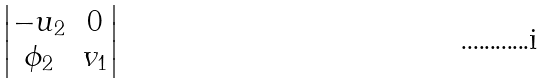<formula> <loc_0><loc_0><loc_500><loc_500>\begin{vmatrix} - u _ { 2 } & 0 \\ \phi _ { 2 } & v _ { 1 } \end{vmatrix}</formula> 